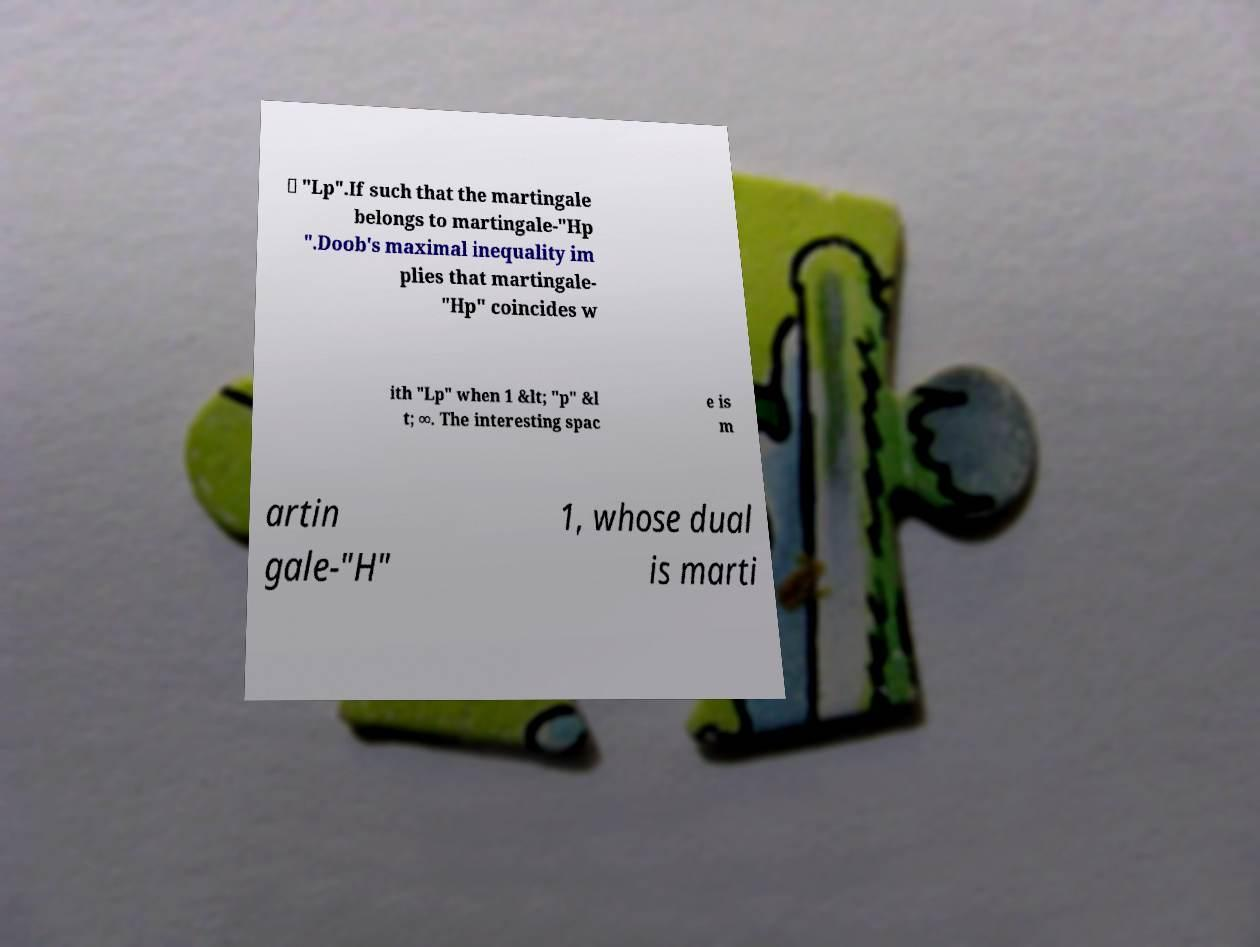Please identify and transcribe the text found in this image. ∈ "Lp".If such that the martingale belongs to martingale-"Hp ".Doob's maximal inequality im plies that martingale- "Hp" coincides w ith "Lp" when 1 &lt; "p" &l t; ∞. The interesting spac e is m artin gale-"H" 1, whose dual is marti 